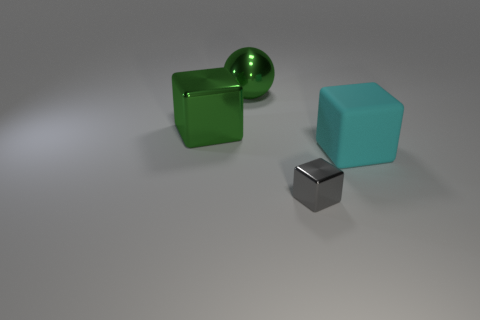The object that is the same color as the metallic sphere is what shape?
Provide a short and direct response. Cube. Is there a metallic object of the same color as the sphere?
Give a very brief answer. Yes. How many other things are the same size as the gray metal block?
Make the answer very short. 0. What is the material of the large block to the right of the ball?
Your answer should be compact. Rubber. What shape is the large metallic object that is on the right side of the cube left of the big object that is behind the green block?
Make the answer very short. Sphere. Is the matte cube the same size as the metal ball?
Provide a short and direct response. Yes. What number of objects are either big blue cylinders or big objects that are to the right of the gray object?
Your answer should be very brief. 1. What number of objects are things that are behind the gray metal thing or metal blocks that are in front of the big cyan object?
Offer a very short reply. 4. Are there any big green shiny cubes behind the cyan block?
Your response must be concise. Yes. The metallic block that is in front of the large cube that is on the right side of the metal block that is in front of the big cyan cube is what color?
Your answer should be very brief. Gray. 